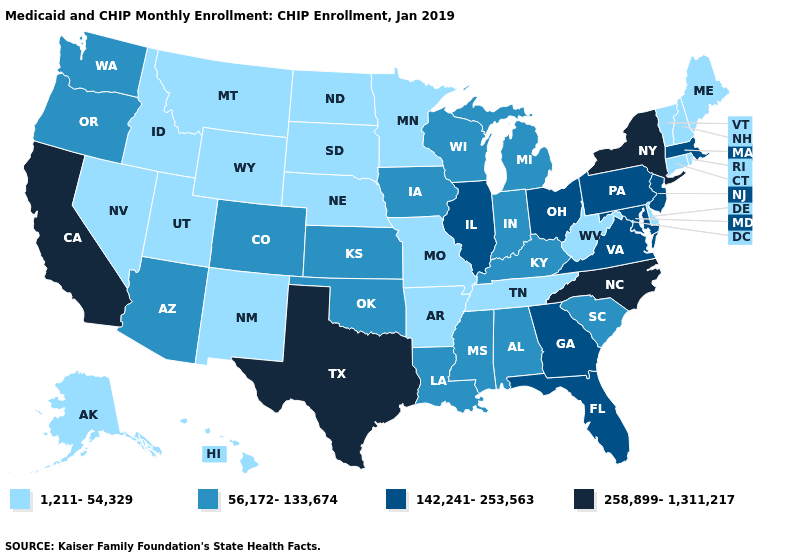What is the value of New York?
Write a very short answer. 258,899-1,311,217. What is the highest value in the South ?
Quick response, please. 258,899-1,311,217. Name the states that have a value in the range 142,241-253,563?
Write a very short answer. Florida, Georgia, Illinois, Maryland, Massachusetts, New Jersey, Ohio, Pennsylvania, Virginia. Which states hav the highest value in the South?
Answer briefly. North Carolina, Texas. Does Arkansas have the lowest value in the South?
Short answer required. Yes. What is the value of West Virginia?
Answer briefly. 1,211-54,329. Does California have the same value as Texas?
Concise answer only. Yes. Name the states that have a value in the range 142,241-253,563?
Write a very short answer. Florida, Georgia, Illinois, Maryland, Massachusetts, New Jersey, Ohio, Pennsylvania, Virginia. What is the value of New Jersey?
Write a very short answer. 142,241-253,563. What is the highest value in states that border Oregon?
Concise answer only. 258,899-1,311,217. What is the value of Indiana?
Concise answer only. 56,172-133,674. What is the lowest value in the West?
Answer briefly. 1,211-54,329. Is the legend a continuous bar?
Give a very brief answer. No. What is the value of New Hampshire?
Quick response, please. 1,211-54,329. Which states hav the highest value in the South?
Keep it brief. North Carolina, Texas. 